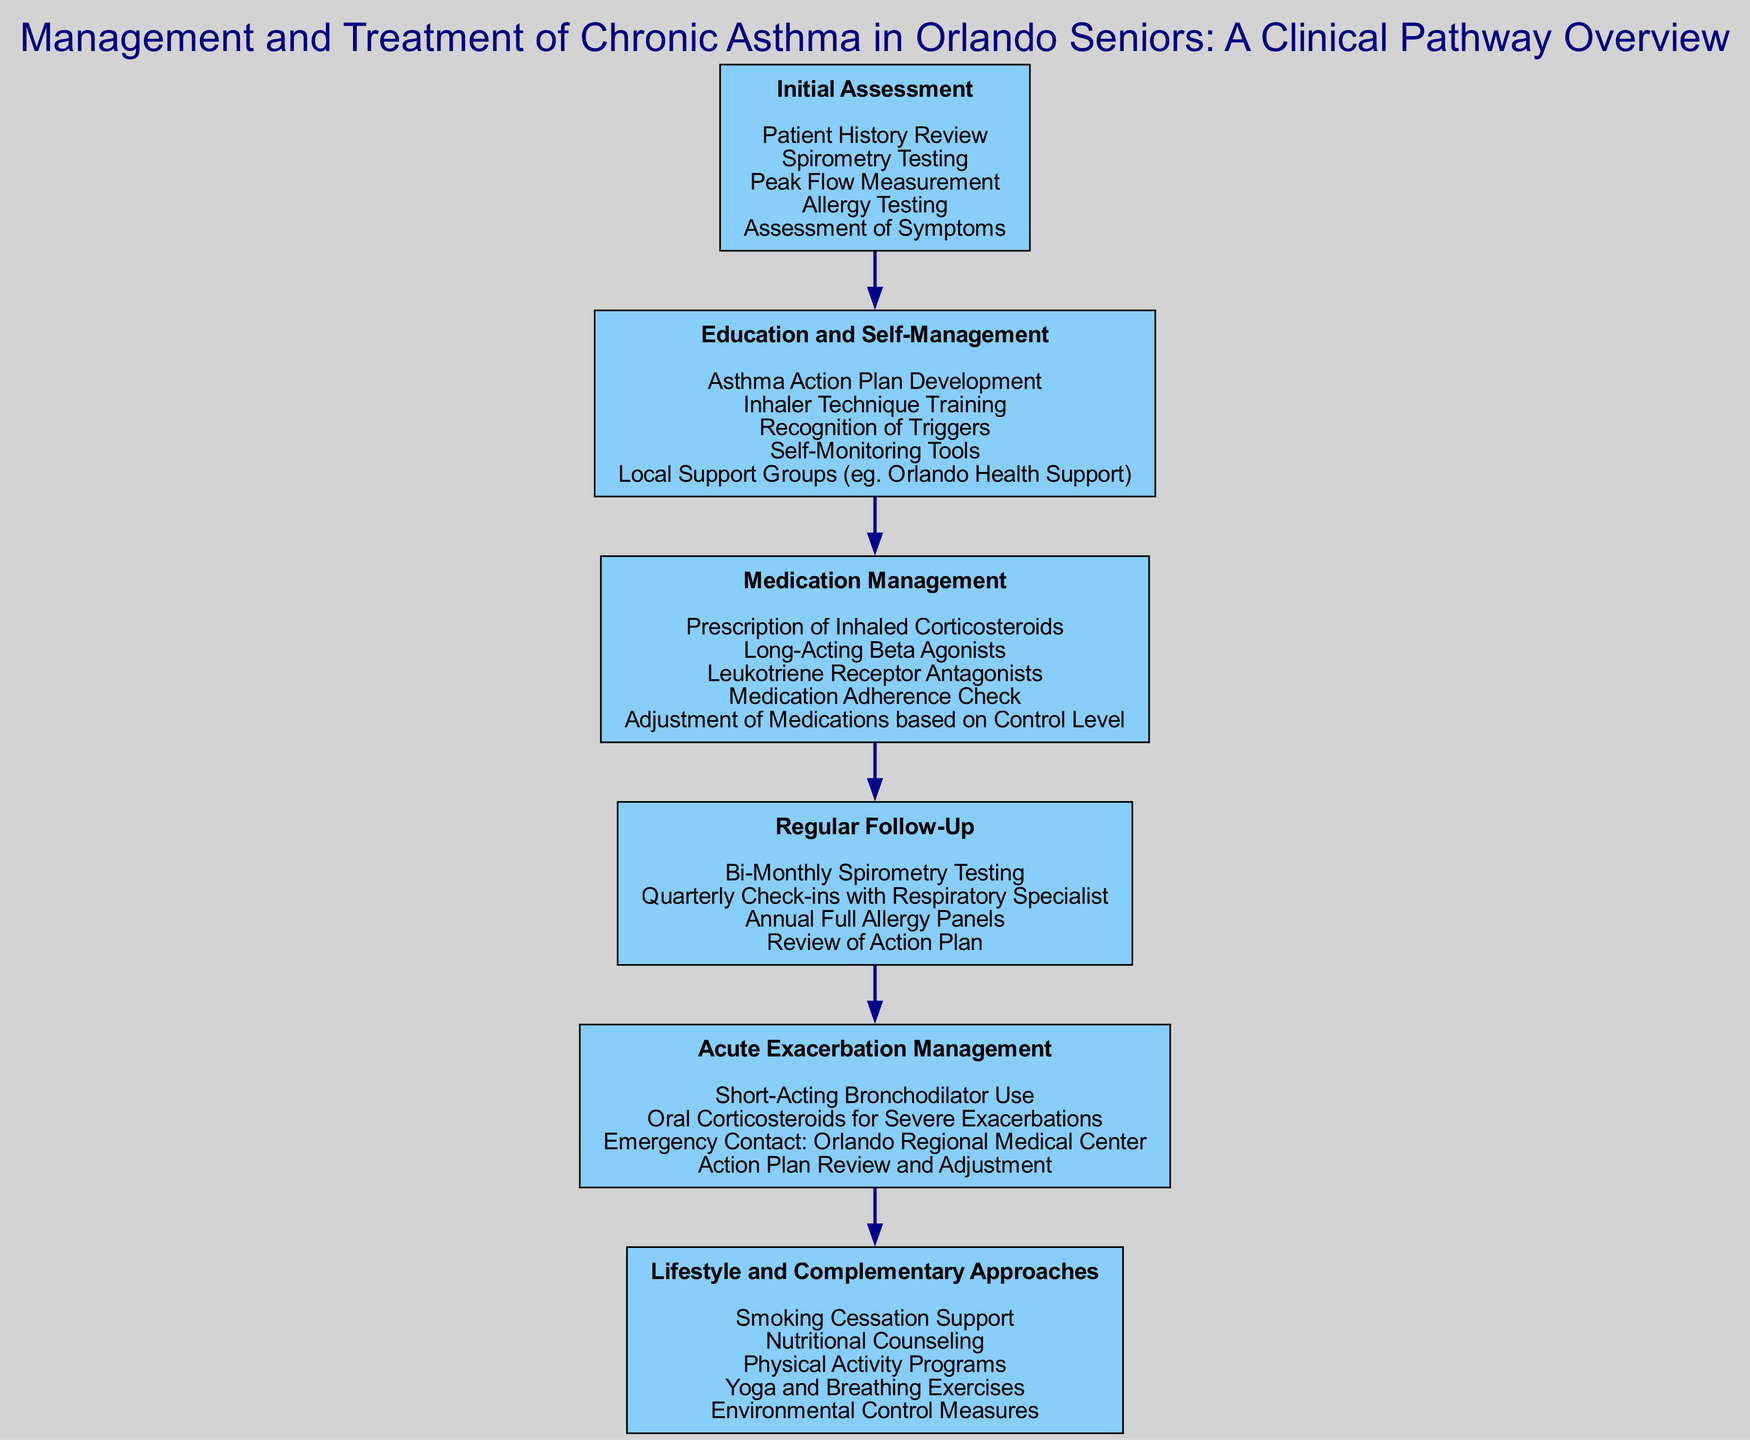What is the first node in the pathway? The first node, labeled "Initial Assessment," is the starting point of the clinical pathway, indicating the first step in managing and treating chronic asthma in seniors.
Answer: Initial Assessment How many components are included in "Education and Self-Management"? By counting the listed components under "Education and Self-Management," we see there are five components, which detail various educational and supportive measures for patients.
Answer: 5 What is the last step in the management pathway? The last step shown in the diagram is "Lifestyle and Complementary Approaches," which serves as a culmination of the pathway to address preventative and supportive health measures.
Answer: Lifestyle and Complementary Approaches Which component comes after "Medication Management"? The component that follows "Medication Management" is "Regular Follow-Up," showing the importance of ongoing evaluation after medication adjustments.
Answer: Regular Follow-Up What type of medication is prescribed for acute exacerbations? The pathway indicates that "Short-Acting Bronchodilator Use" is specified for managing acute exacerbations in asthma patients.
Answer: Short-Acting Bronchodilator Use What is emphasized within the "Lifestyle and Complementary Approaches" node? The "Lifestyle and Complementary Approaches" node focuses on holistic health measures, emphasizing the integration of lifestyle changes such as nutritional counseling and environmental control to manage asthma.
Answer: Smoking Cessation Support What node connects "Regular Follow-Up" and "Acute Exacerbation Management"? The nodes are sequential and directly connected; hence, "Regular Follow-Up" connects to "Acute Exacerbation Management," signifying the protocol followed after regular assessments.
Answer: Acute Exacerbation Management How often should spirometry testing be conducted, according to the diagram? The diagram states that spirometry testing should be conducted bi-monthly, ensuring regular monitoring of the patient’s lung function and asthma control.
Answer: Bi-Monthly What is included in the "Medication Management" components? The "Medication Management" includes specific medication types and checks for adherence, showcasing a structured approach to pharmacological treatment of asthma.
Answer: Prescription of Inhaled Corticosteroids, Long-Acting Beta Agonists, Leukotriene Receptor Antagonists, Medication Adherence Check, Adjustment of Medications based on Control Level 